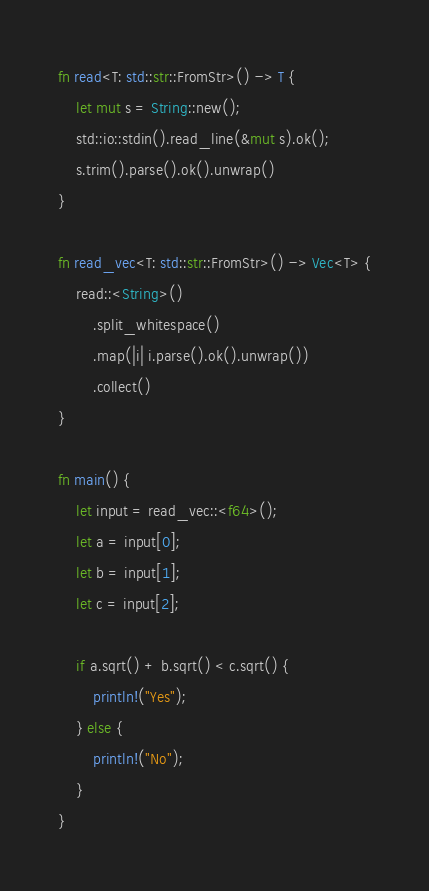<code> <loc_0><loc_0><loc_500><loc_500><_Rust_>fn read<T: std::str::FromStr>() -> T {
    let mut s = String::new();
    std::io::stdin().read_line(&mut s).ok();
    s.trim().parse().ok().unwrap()
}

fn read_vec<T: std::str::FromStr>() -> Vec<T> {
    read::<String>()
        .split_whitespace()
        .map(|i| i.parse().ok().unwrap())
        .collect()
}

fn main() {
    let input = read_vec::<f64>();
    let a = input[0];
    let b = input[1];
    let c = input[2];

    if a.sqrt() + b.sqrt() < c.sqrt() {
        println!("Yes");
    } else {
        println!("No");
    }
}</code> 